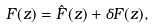<formula> <loc_0><loc_0><loc_500><loc_500>F ( z ) = \hat { F } ( z ) + \delta F ( z ) ,</formula> 